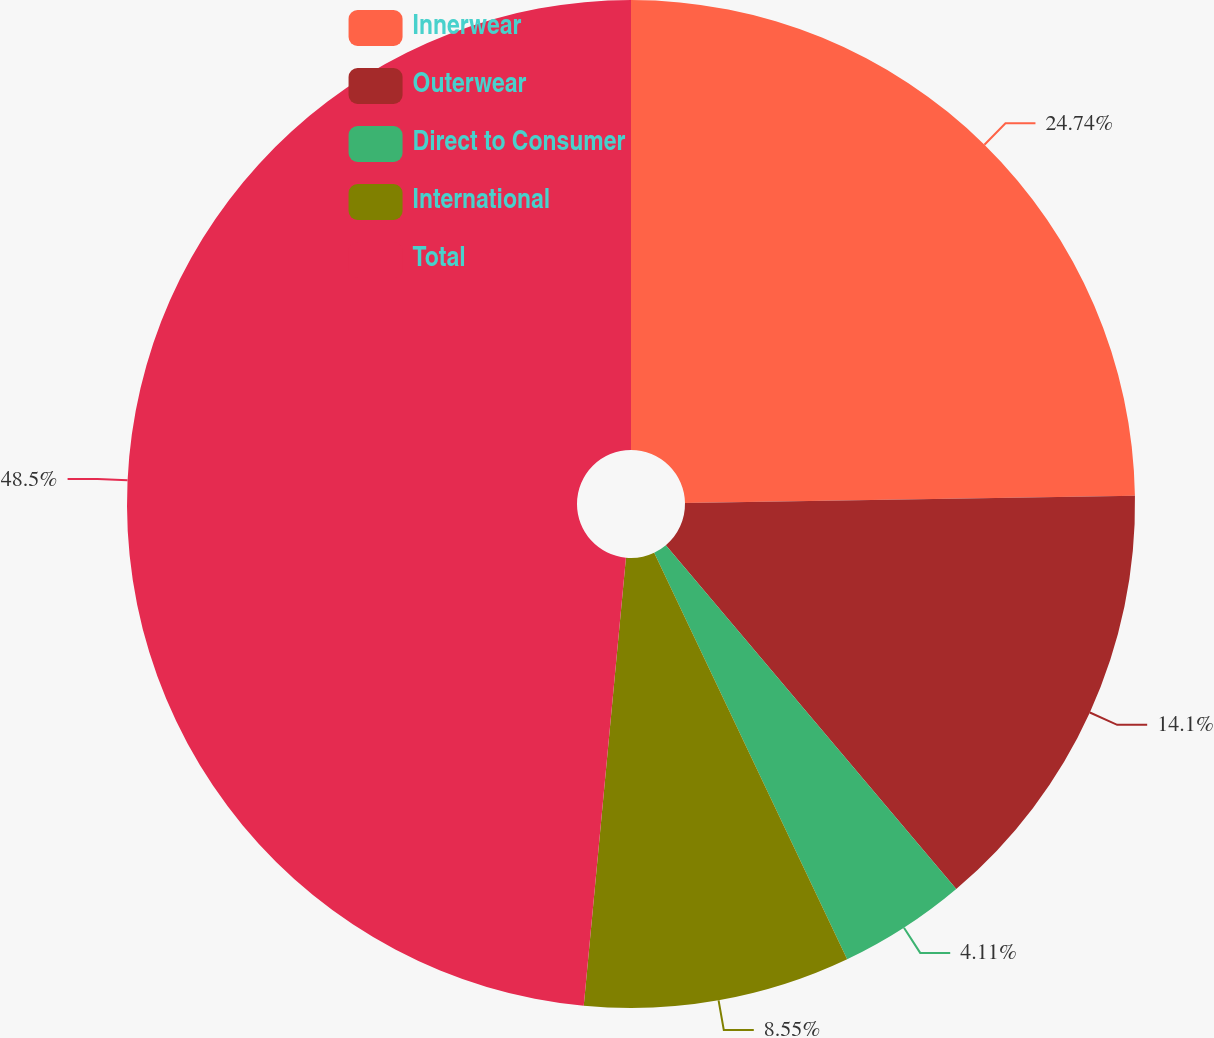<chart> <loc_0><loc_0><loc_500><loc_500><pie_chart><fcel>Innerwear<fcel>Outerwear<fcel>Direct to Consumer<fcel>International<fcel>Total<nl><fcel>24.74%<fcel>14.1%<fcel>4.11%<fcel>8.55%<fcel>48.51%<nl></chart> 